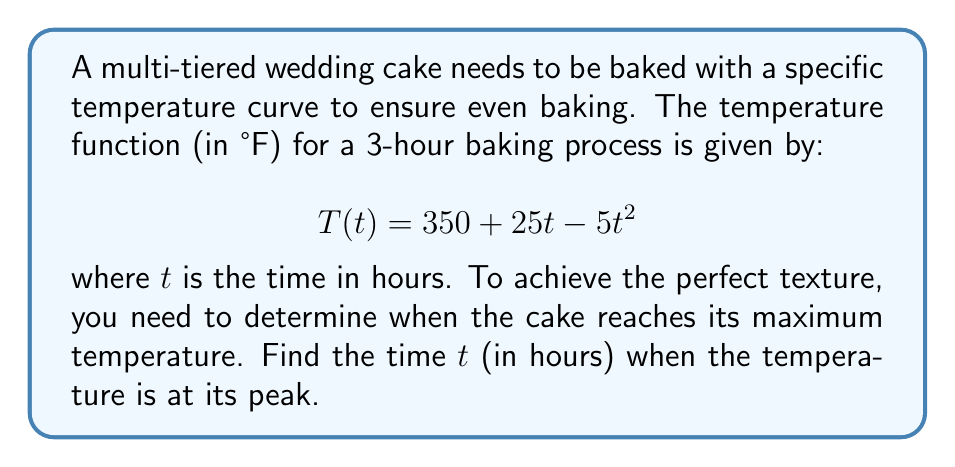Teach me how to tackle this problem. To find the time when the temperature is at its maximum, we need to follow these steps:

1) The maximum point of a function occurs where its derivative equals zero. So, we need to find $T'(t)$ and set it equal to zero.

2) Calculate the derivative of $T(t)$:
   $$T'(t) = \frac{d}{dt}(350 + 25t - 5t^2)$$
   $$T'(t) = 0 + 25 - 10t$$
   $$T'(t) = 25 - 10t$$

3) Set $T'(t) = 0$ and solve for $t$:
   $$25 - 10t = 0$$
   $$-10t = -25$$
   $$t = \frac{25}{10} = 2.5$$

4) To confirm this is a maximum (not a minimum), we can check the second derivative:
   $$T''(t) = -10$$
   Since $T''(t)$ is negative, we confirm that $t = 2.5$ gives a maximum.

5) Therefore, the temperature reaches its peak after 2.5 hours of baking.
Answer: $2.5$ hours 